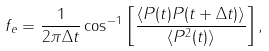Convert formula to latex. <formula><loc_0><loc_0><loc_500><loc_500>f _ { e } = { \frac { 1 } { 2 \pi \Delta t } } \cos ^ { - 1 } \left [ { \frac { \langle P ( t ) P ( t + \Delta t ) \rangle } { \langle P ^ { 2 } ( t ) \rangle } } \right ] ,</formula> 